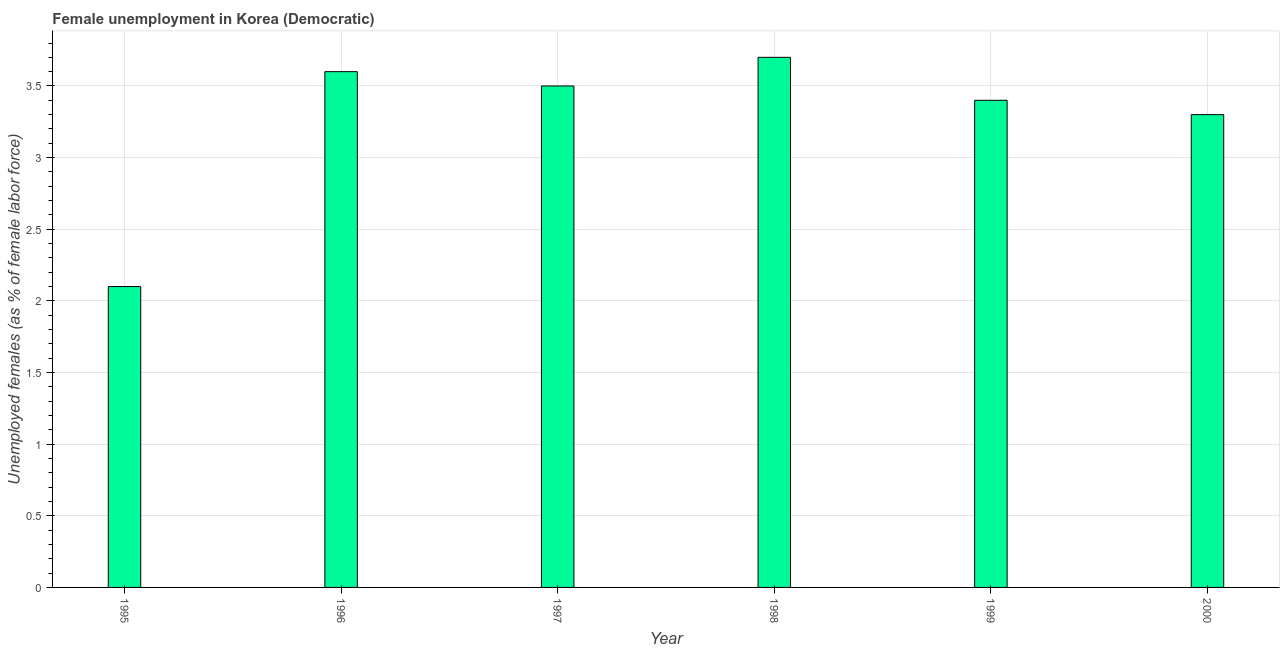Does the graph contain any zero values?
Give a very brief answer. No. Does the graph contain grids?
Keep it short and to the point. Yes. What is the title of the graph?
Provide a short and direct response. Female unemployment in Korea (Democratic). What is the label or title of the Y-axis?
Make the answer very short. Unemployed females (as % of female labor force). What is the unemployed females population in 1995?
Give a very brief answer. 2.1. Across all years, what is the maximum unemployed females population?
Ensure brevity in your answer.  3.7. Across all years, what is the minimum unemployed females population?
Provide a succinct answer. 2.1. What is the sum of the unemployed females population?
Keep it short and to the point. 19.6. What is the average unemployed females population per year?
Keep it short and to the point. 3.27. What is the median unemployed females population?
Give a very brief answer. 3.45. In how many years, is the unemployed females population greater than 1.7 %?
Provide a short and direct response. 6. What is the ratio of the unemployed females population in 1995 to that in 1996?
Keep it short and to the point. 0.58. What is the difference between the highest and the second highest unemployed females population?
Provide a short and direct response. 0.1. What is the difference between the highest and the lowest unemployed females population?
Your answer should be very brief. 1.6. How many bars are there?
Provide a short and direct response. 6. Are all the bars in the graph horizontal?
Make the answer very short. No. How many years are there in the graph?
Offer a very short reply. 6. What is the difference between two consecutive major ticks on the Y-axis?
Your response must be concise. 0.5. Are the values on the major ticks of Y-axis written in scientific E-notation?
Your response must be concise. No. What is the Unemployed females (as % of female labor force) in 1995?
Make the answer very short. 2.1. What is the Unemployed females (as % of female labor force) in 1996?
Ensure brevity in your answer.  3.6. What is the Unemployed females (as % of female labor force) in 1998?
Provide a succinct answer. 3.7. What is the Unemployed females (as % of female labor force) of 1999?
Your answer should be very brief. 3.4. What is the Unemployed females (as % of female labor force) of 2000?
Your answer should be compact. 3.3. What is the difference between the Unemployed females (as % of female labor force) in 1995 and 2000?
Provide a succinct answer. -1.2. What is the difference between the Unemployed females (as % of female labor force) in 1996 and 1998?
Your response must be concise. -0.1. What is the difference between the Unemployed females (as % of female labor force) in 1996 and 1999?
Provide a short and direct response. 0.2. What is the difference between the Unemployed females (as % of female labor force) in 1996 and 2000?
Give a very brief answer. 0.3. What is the difference between the Unemployed females (as % of female labor force) in 1997 and 1998?
Keep it short and to the point. -0.2. What is the difference between the Unemployed females (as % of female labor force) in 1999 and 2000?
Offer a terse response. 0.1. What is the ratio of the Unemployed females (as % of female labor force) in 1995 to that in 1996?
Make the answer very short. 0.58. What is the ratio of the Unemployed females (as % of female labor force) in 1995 to that in 1998?
Make the answer very short. 0.57. What is the ratio of the Unemployed females (as % of female labor force) in 1995 to that in 1999?
Provide a succinct answer. 0.62. What is the ratio of the Unemployed females (as % of female labor force) in 1995 to that in 2000?
Your response must be concise. 0.64. What is the ratio of the Unemployed females (as % of female labor force) in 1996 to that in 1999?
Ensure brevity in your answer.  1.06. What is the ratio of the Unemployed females (as % of female labor force) in 1996 to that in 2000?
Offer a terse response. 1.09. What is the ratio of the Unemployed females (as % of female labor force) in 1997 to that in 1998?
Your response must be concise. 0.95. What is the ratio of the Unemployed females (as % of female labor force) in 1997 to that in 2000?
Keep it short and to the point. 1.06. What is the ratio of the Unemployed females (as % of female labor force) in 1998 to that in 1999?
Give a very brief answer. 1.09. What is the ratio of the Unemployed females (as % of female labor force) in 1998 to that in 2000?
Give a very brief answer. 1.12. 